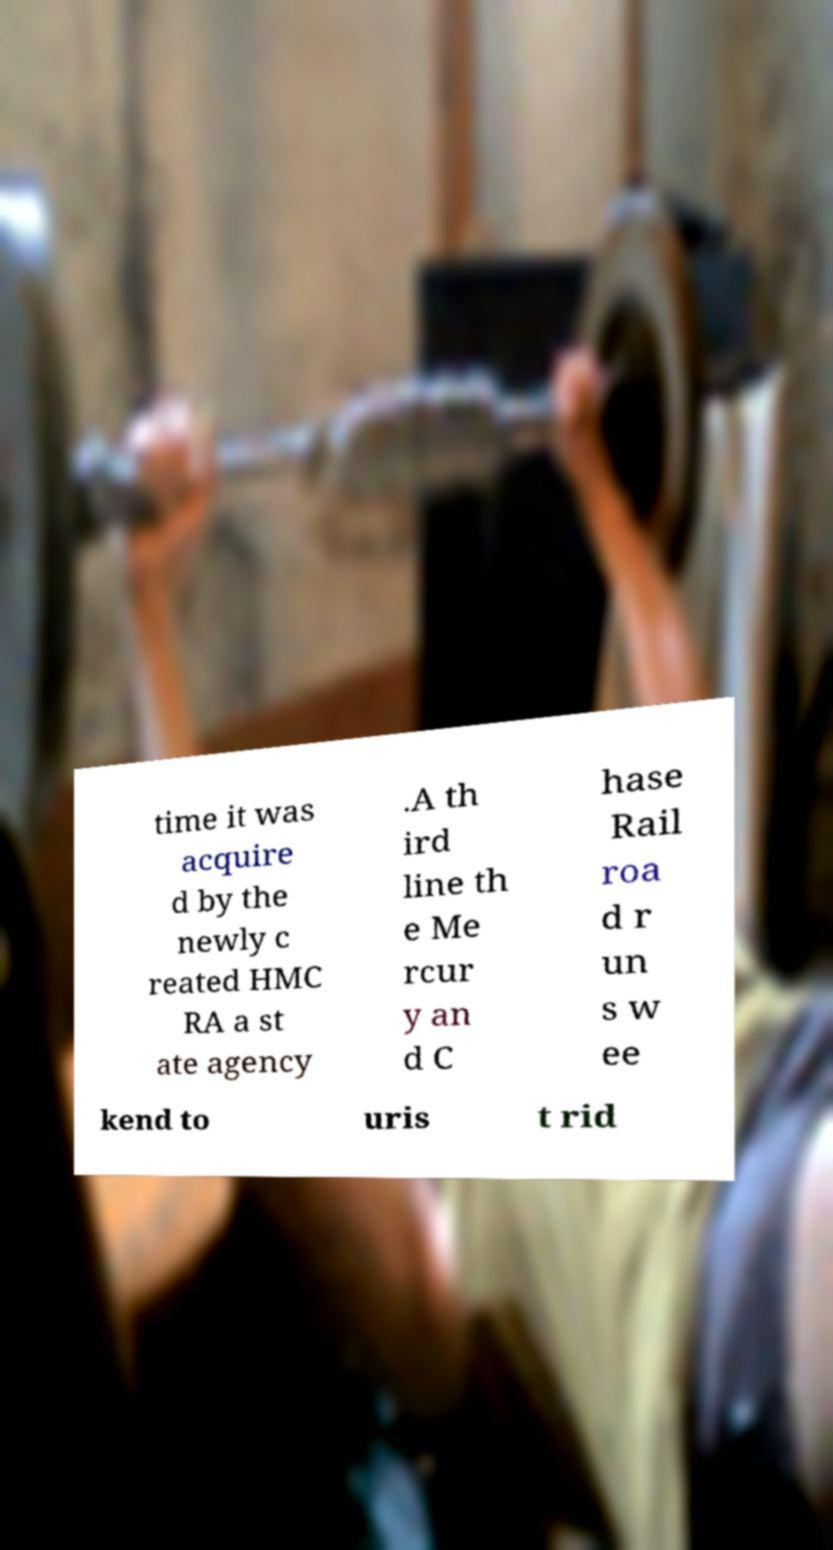There's text embedded in this image that I need extracted. Can you transcribe it verbatim? time it was acquire d by the newly c reated HMC RA a st ate agency .A th ird line th e Me rcur y an d C hase Rail roa d r un s w ee kend to uris t rid 